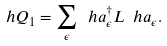<formula> <loc_0><loc_0><loc_500><loc_500>\ h Q _ { 1 } = \sum _ { \epsilon } \ h a _ { \epsilon } ^ { \dagger } L \ h a _ { \epsilon } .</formula> 